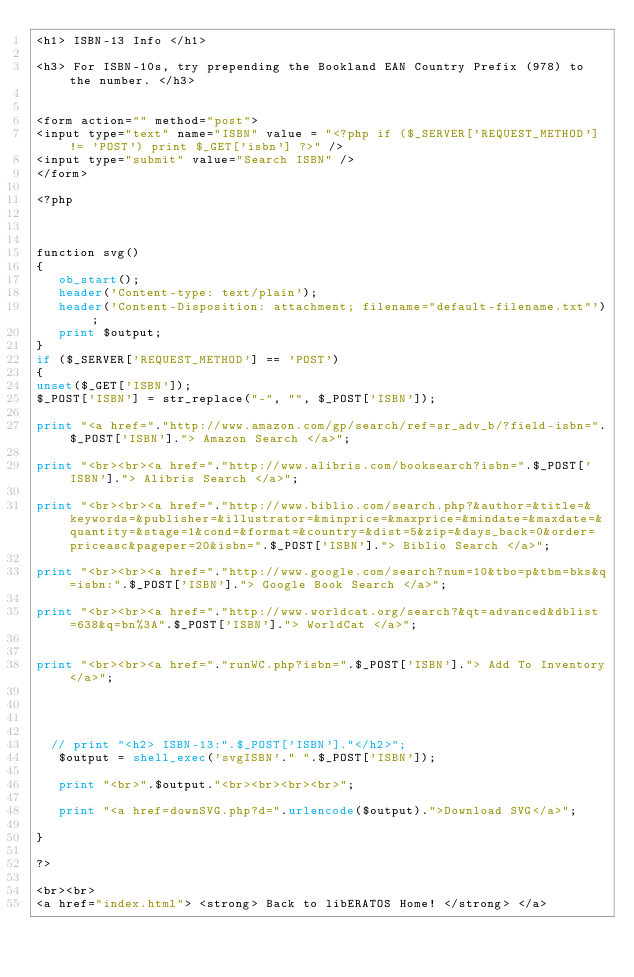Convert code to text. <code><loc_0><loc_0><loc_500><loc_500><_PHP_><h1> ISBN-13 Info </h1>

<h3> For ISBN-10s, try prepending the Bookland EAN Country Prefix (978) to the number. </h3>


<form action="" method="post">
<input type="text" name="ISBN" value = "<?php if ($_SERVER['REQUEST_METHOD'] != 'POST') print $_GET['isbn'] ?>" />
<input type="submit" value="Search ISBN" />
</form>

<?php



function svg()
{
   ob_start();
   header('Content-type: text/plain');
   header('Content-Disposition: attachment; filename="default-filename.txt"');
   print $output;
}
if ($_SERVER['REQUEST_METHOD'] == 'POST')
{
unset($_GET['ISBN']);
$_POST['ISBN'] = str_replace("-", "", $_POST['ISBN']);

print "<a href="."http://www.amazon.com/gp/search/ref=sr_adv_b/?field-isbn=".$_POST['ISBN']."> Amazon Search </a>";

print "<br><br><a href="."http://www.alibris.com/booksearch?isbn=".$_POST['ISBN']."> Alibris Search </a>";

print "<br><br><a href="."http://www.biblio.com/search.php?&author=&title=&keywords=&publisher=&illustrator=&minprice=&maxprice=&mindate=&maxdate=&quantity=&stage=1&cond=&format=&country=&dist=5&zip=&days_back=0&order=priceasc&pageper=20&isbn=".$_POST['ISBN']."> Biblio Search </a>";

print "<br><br><a href="."http://www.google.com/search?num=10&tbo=p&tbm=bks&q=isbn:".$_POST['ISBN']."> Google Book Search </a>";

print "<br><br><a href="."http://www.worldcat.org/search?&qt=advanced&dblist=638&q=bn%3A".$_POST['ISBN']."> WorldCat </a>";


print "<br><br><a href="."runWC.php?isbn=".$_POST['ISBN']."> Add To Inventory</a>";




  // print "<h2> ISBN-13:".$_POST['ISBN']."</h2>";
   $output = shell_exec('svgISBN'." ".$_POST['ISBN']);
   
   print "<br>".$output."<br><br><br><br>";

   print "<a href=downSVG.php?d=".urlencode($output).">Download SVG</a>";

}

?>

<br><br>
<a href="index.html"> <strong> Back to libERATOS Home! </strong> </a></code> 